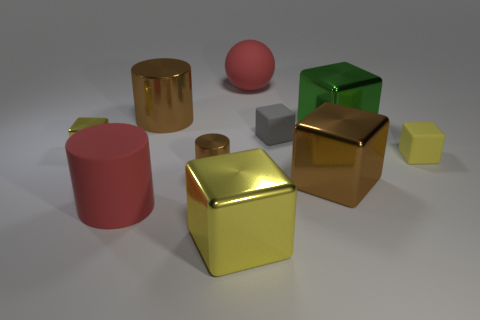Is there any other thing that is the same color as the small shiny cylinder?
Make the answer very short. Yes. There is a matte object that is behind the large metallic cube behind the tiny brown object; what color is it?
Your answer should be compact. Red. Is the number of red balls that are on the left side of the big yellow metal object less than the number of big green things that are on the right side of the large brown metallic cylinder?
Make the answer very short. Yes. What is the material of the big object that is the same color as the matte cylinder?
Your response must be concise. Rubber. What number of objects are yellow rubber things right of the big red rubber sphere or cyan matte spheres?
Offer a very short reply. 1. Is the size of the red object behind the gray cube the same as the small gray object?
Your answer should be compact. No. Are there fewer red objects that are right of the gray thing than cyan metal spheres?
Provide a succinct answer. No. There is a cylinder that is the same size as the gray object; what is its material?
Your answer should be compact. Metal. What number of tiny things are either gray rubber blocks or red matte cylinders?
Give a very brief answer. 1. How many objects are either brown shiny cylinders in front of the big green shiny cube or large red objects that are in front of the large brown cylinder?
Offer a very short reply. 2. 